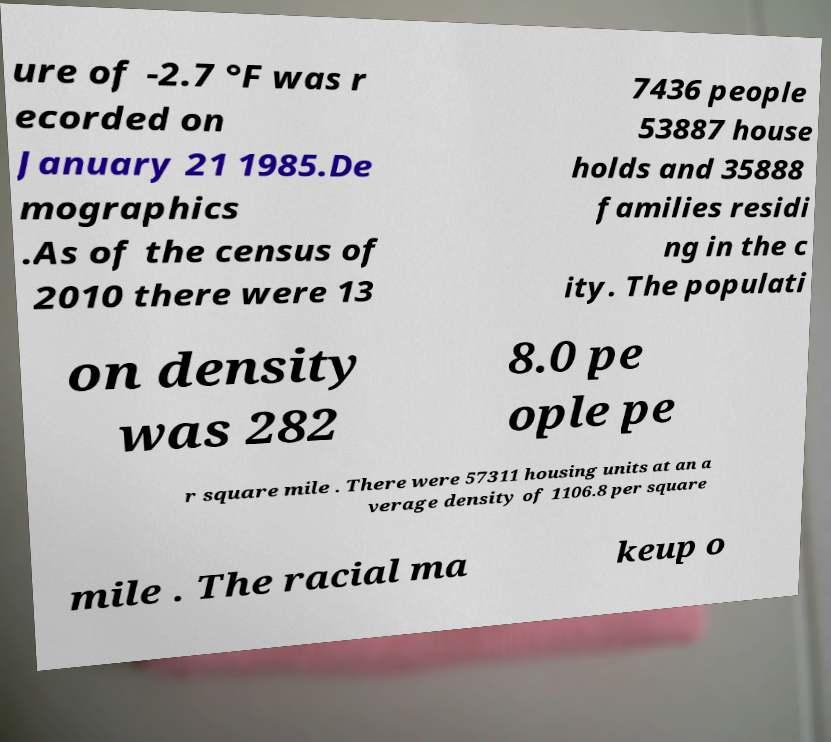Could you extract and type out the text from this image? ure of -2.7 °F was r ecorded on January 21 1985.De mographics .As of the census of 2010 there were 13 7436 people 53887 house holds and 35888 families residi ng in the c ity. The populati on density was 282 8.0 pe ople pe r square mile . There were 57311 housing units at an a verage density of 1106.8 per square mile . The racial ma keup o 